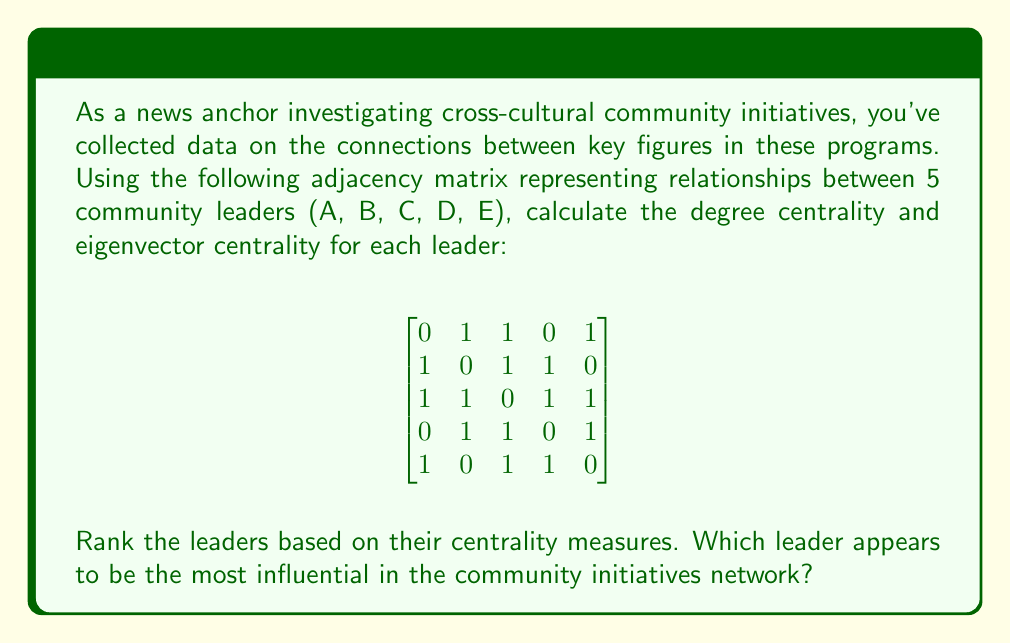Teach me how to tackle this problem. To solve this problem, we need to calculate two centrality measures: degree centrality and eigenvector centrality.

1. Degree Centrality:
Degree centrality is the number of direct connections a node has. For an undirected graph, it's the sum of each row (or column) in the adjacency matrix.

A: 3
B: 3
C: 4
D: 3
E: 3

2. Eigenvector Centrality:
Eigenvector centrality takes into account not just the number of connections, but also the importance of those connections. We need to find the eigenvector corresponding to the largest eigenvalue of the adjacency matrix.

Using power iteration method:
a) Start with an initial vector $v_0 = [1, 1, 1, 1, 1]^T$
b) Multiply the adjacency matrix by $v_0$
c) Normalize the resulting vector
d) Repeat until convergence

After several iterations, we get the eigenvector:

$$v \approx [0.4472, 0.4472, 0.5477, 0.4472, 0.4472]^T$$

Normalizing to sum to 1:

A: 0.1915
B: 0.1915
C: 0.2344
D: 0.1915
E: 0.1915

Ranking based on centrality measures:

Degree Centrality: C > A = B = D = E
Eigenvector Centrality: C > A = B = D = E

Leader C appears to be the most influential in the community initiatives network, as they have the highest degree centrality and eigenvector centrality.
Answer: Degree Centrality: A: 3, B: 3, C: 4, D: 3, E: 3
Eigenvector Centrality: A: 0.1915, B: 0.1915, C: 0.2344, D: 0.1915, E: 0.1915
Ranking: C > A = B = D = E
Most influential leader: C 